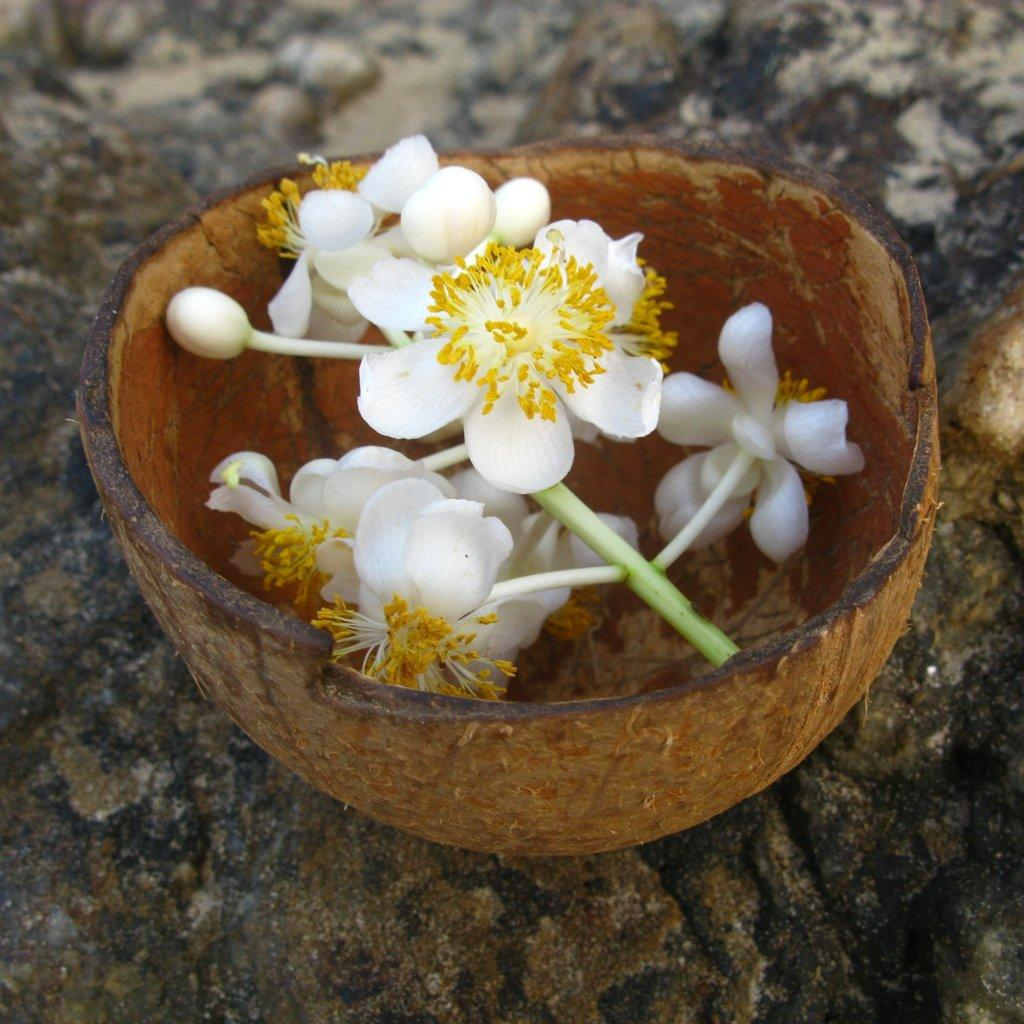What is the main object in the image? There is a dry coconut shell in the image. Where is the dry coconut shell located? The dry coconut shell is on a rock. What is inside the dry coconut shell? There are flowers and buds in the dry coconut shell. What type of bread is being served for dinner in the image? There is no bread or dinner present in the image; it features a dry coconut shell with flowers and buds. 